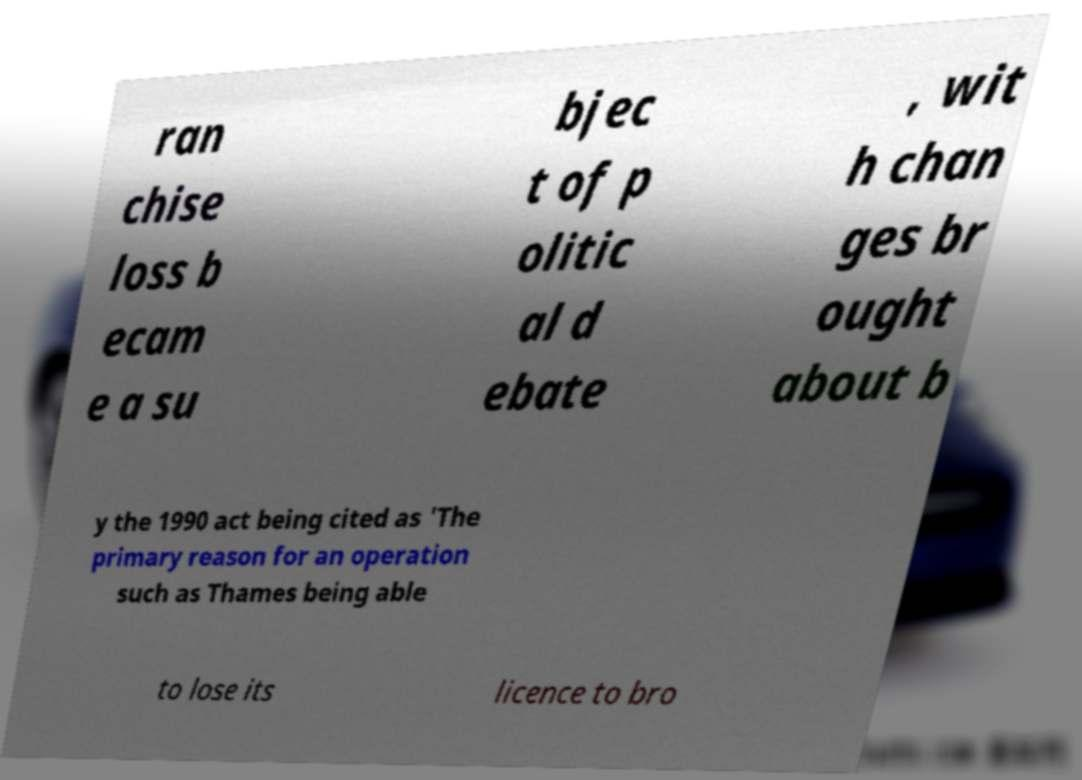I need the written content from this picture converted into text. Can you do that? ran chise loss b ecam e a su bjec t of p olitic al d ebate , wit h chan ges br ought about b y the 1990 act being cited as 'The primary reason for an operation such as Thames being able to lose its licence to bro 